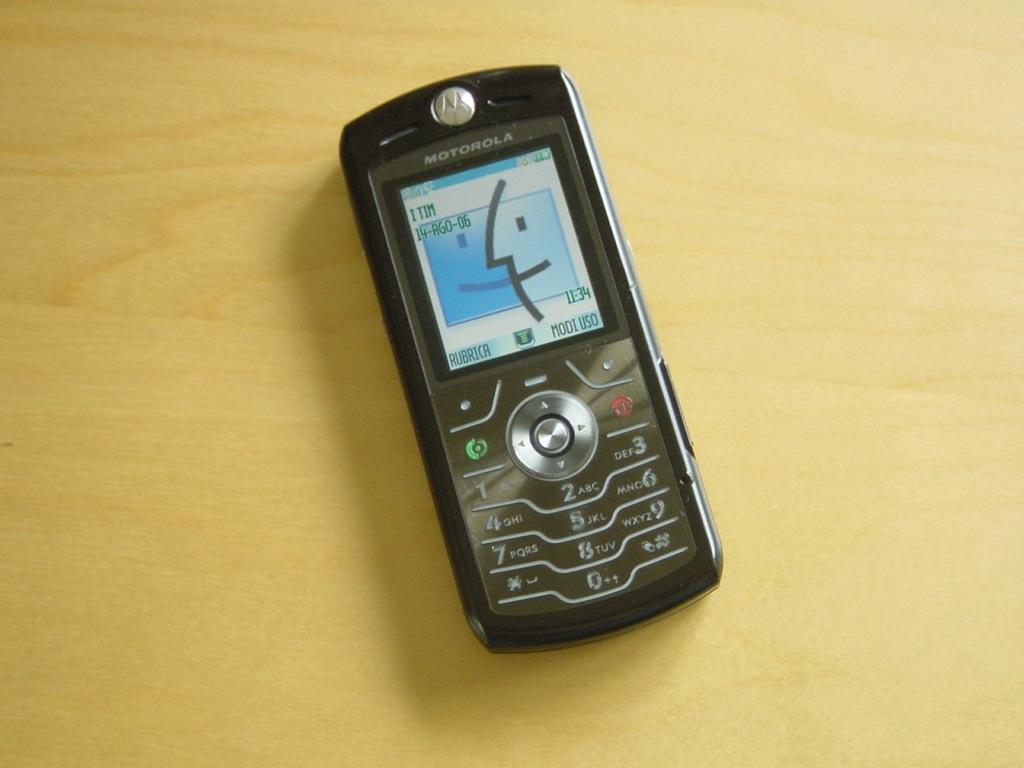What brand of phone is this?
Provide a succinct answer. Motorola. 